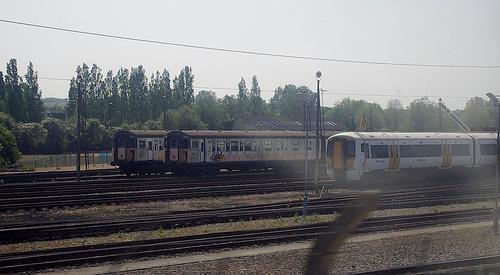How many trains are visible?
Give a very brief answer. 3. 